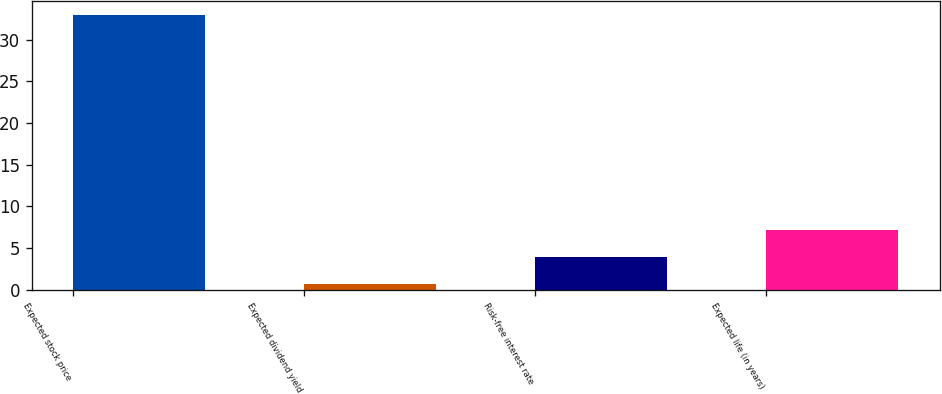Convert chart to OTSL. <chart><loc_0><loc_0><loc_500><loc_500><bar_chart><fcel>Expected stock price<fcel>Expected dividend yield<fcel>Risk-free interest rate<fcel>Expected life (in years)<nl><fcel>33<fcel>0.7<fcel>3.93<fcel>7.16<nl></chart> 